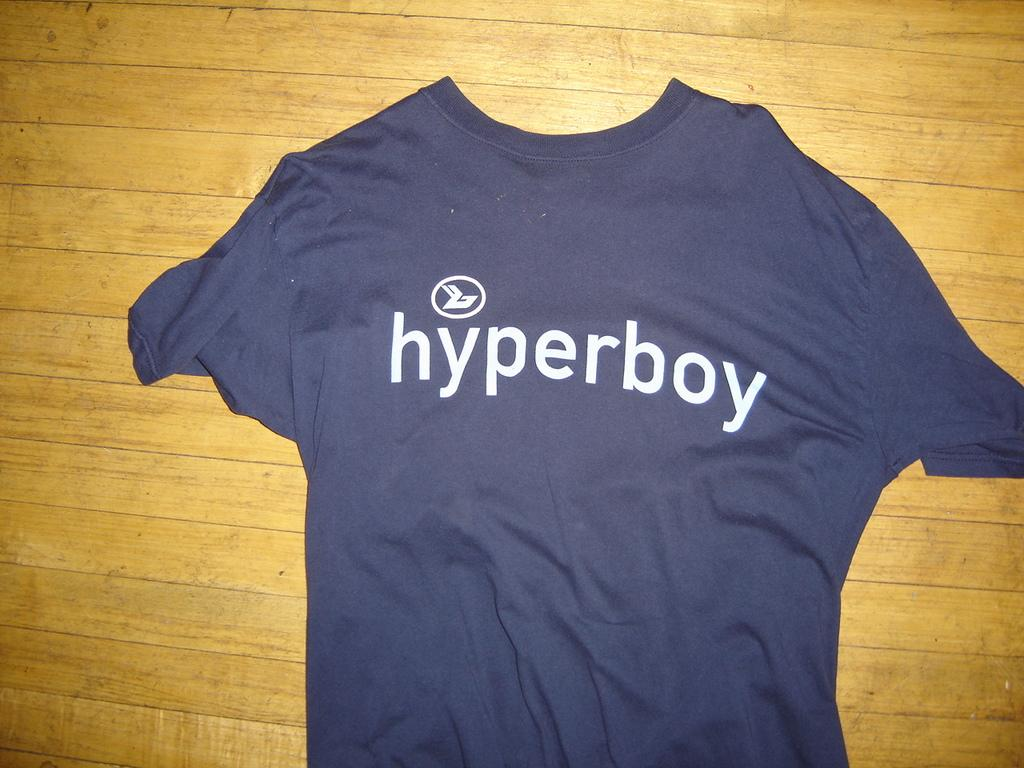<image>
Create a compact narrative representing the image presented. Blue shirt which says Hyperboy on a wooden table. 